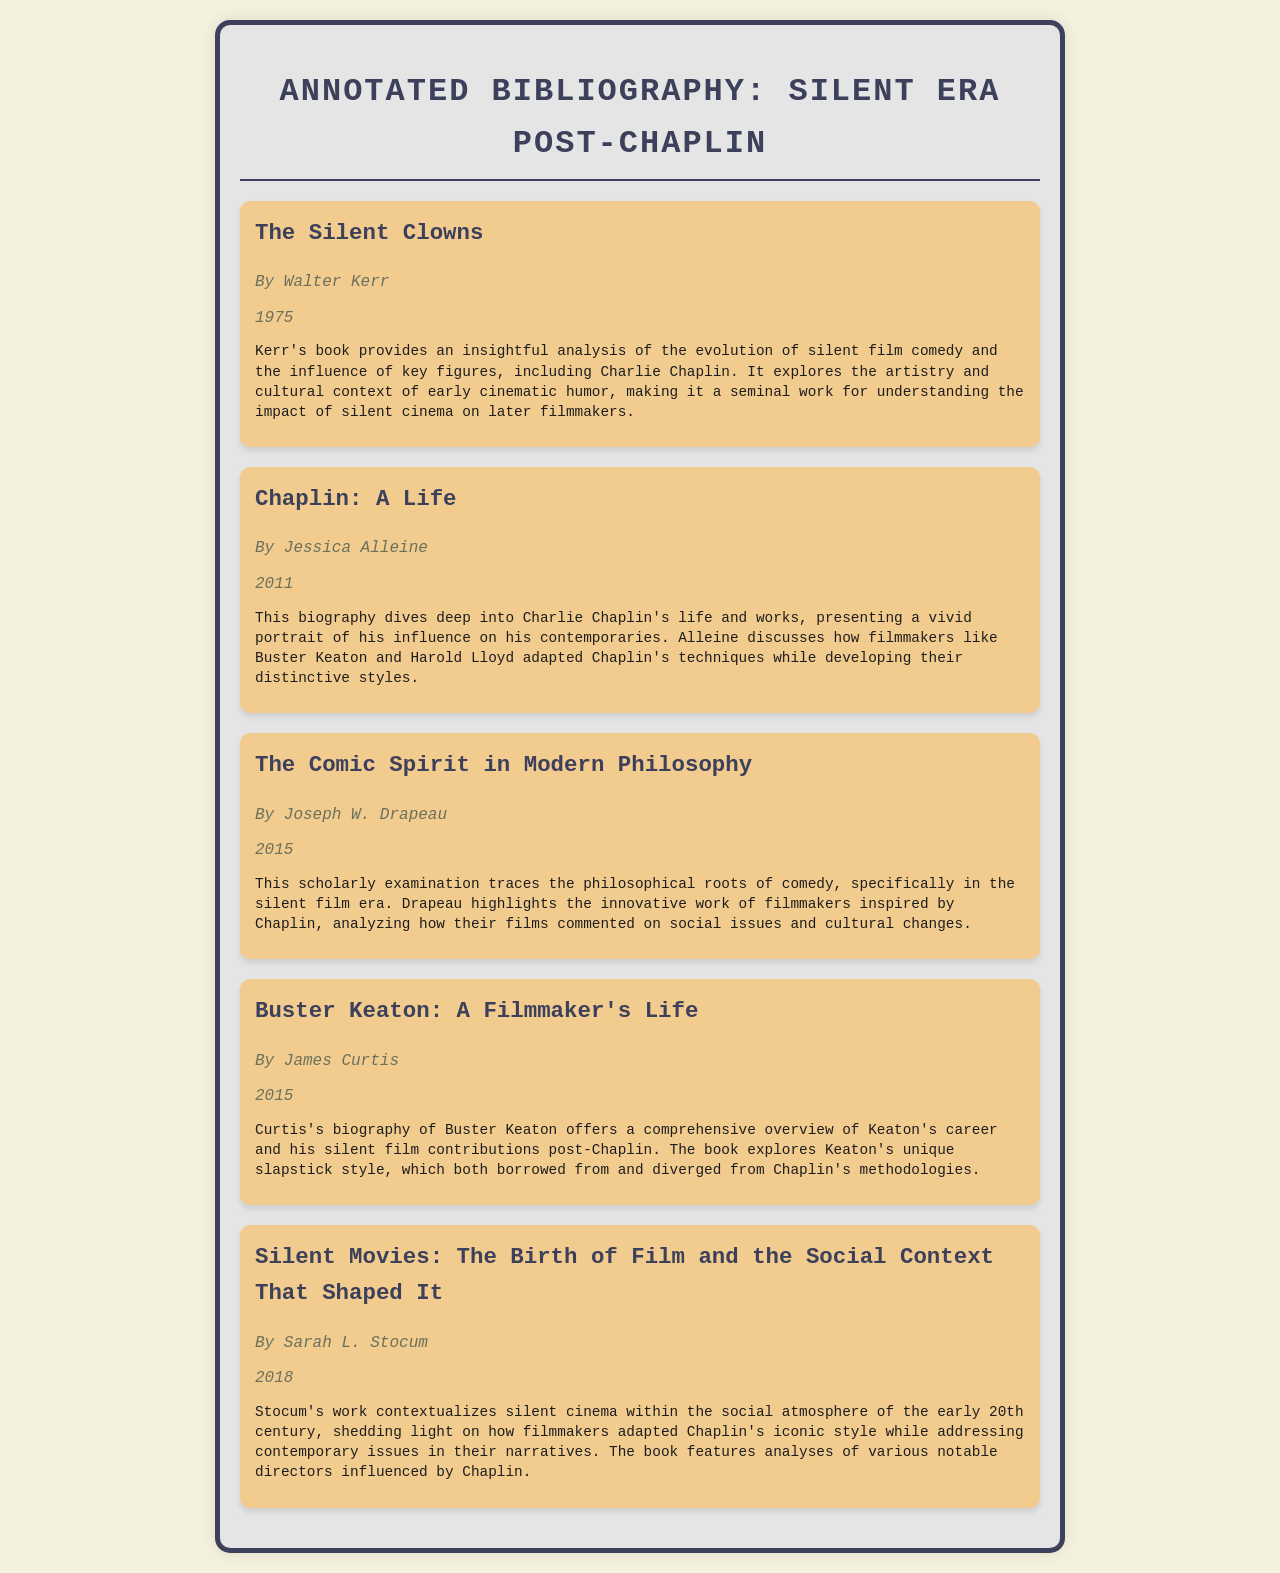What is the title of Walter Kerr's book? Walter Kerr's book is mentioned in the document with its title, which serves as a significant reference in silent film studies.
Answer: The Silent Clowns Who is the author of "Chaplin: A Life"? The document states that this biography was written by Jessica Alleine, highlighting her work's contribution to understanding Chaplin's influence.
Answer: Jessica Alleine In what year was "The Comic Spirit in Modern Philosophy" published? This question asks for the publication year of a specific work discussed in the document, which is listed alongside the book's details.
Answer: 2015 Which filmmaker's unique slapstick style is explored in James Curtis's biography? The document specifically notes that Buster Keaton's contributions and style are examined, referencing his connection to Chaplin.
Answer: Buster Keaton What is the primary focus of Sarah L. Stocum's work? The document describes Stocum's work as contextualizing silent cinema within a specific social atmosphere, which reflects her scholarly approach.
Answer: Social context How many books are listed in the annotated bibliography? This question requires counting the total entries in the document, which indicates the breadth of the annotated bibliography.
Answer: Five 